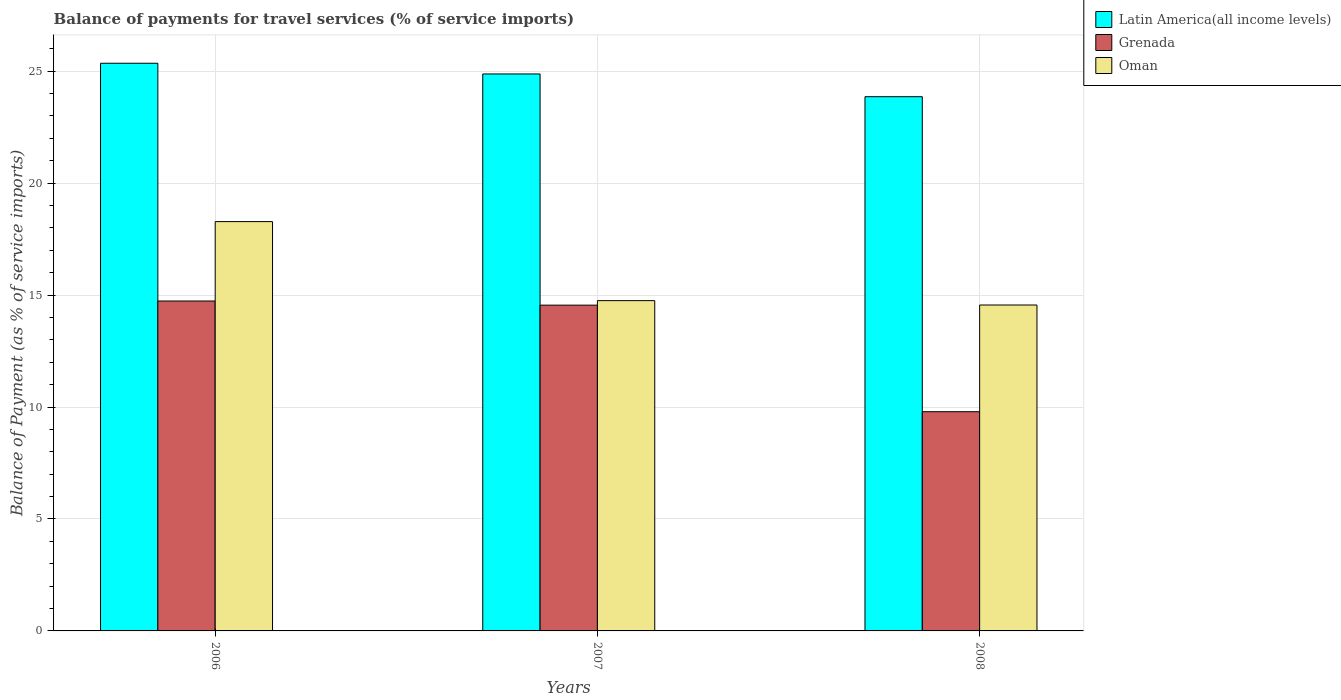How many different coloured bars are there?
Make the answer very short. 3. How many groups of bars are there?
Keep it short and to the point. 3. Are the number of bars on each tick of the X-axis equal?
Your answer should be compact. Yes. How many bars are there on the 3rd tick from the right?
Give a very brief answer. 3. What is the label of the 2nd group of bars from the left?
Provide a short and direct response. 2007. What is the balance of payments for travel services in Oman in 2007?
Provide a succinct answer. 14.75. Across all years, what is the maximum balance of payments for travel services in Oman?
Offer a very short reply. 18.28. Across all years, what is the minimum balance of payments for travel services in Latin America(all income levels)?
Offer a terse response. 23.86. In which year was the balance of payments for travel services in Latin America(all income levels) maximum?
Keep it short and to the point. 2006. In which year was the balance of payments for travel services in Latin America(all income levels) minimum?
Offer a terse response. 2008. What is the total balance of payments for travel services in Oman in the graph?
Offer a terse response. 47.59. What is the difference between the balance of payments for travel services in Latin America(all income levels) in 2006 and that in 2008?
Your answer should be compact. 1.49. What is the difference between the balance of payments for travel services in Latin America(all income levels) in 2007 and the balance of payments for travel services in Oman in 2008?
Provide a short and direct response. 10.32. What is the average balance of payments for travel services in Grenada per year?
Offer a very short reply. 13.03. In the year 2006, what is the difference between the balance of payments for travel services in Oman and balance of payments for travel services in Latin America(all income levels)?
Give a very brief answer. -7.07. In how many years, is the balance of payments for travel services in Oman greater than 2 %?
Your response must be concise. 3. What is the ratio of the balance of payments for travel services in Grenada in 2006 to that in 2007?
Provide a succinct answer. 1.01. Is the balance of payments for travel services in Grenada in 2006 less than that in 2007?
Ensure brevity in your answer.  No. What is the difference between the highest and the second highest balance of payments for travel services in Grenada?
Offer a terse response. 0.18. What is the difference between the highest and the lowest balance of payments for travel services in Latin America(all income levels)?
Offer a terse response. 1.49. Is the sum of the balance of payments for travel services in Latin America(all income levels) in 2006 and 2008 greater than the maximum balance of payments for travel services in Grenada across all years?
Keep it short and to the point. Yes. What does the 3rd bar from the left in 2007 represents?
Make the answer very short. Oman. What does the 2nd bar from the right in 2007 represents?
Your response must be concise. Grenada. Is it the case that in every year, the sum of the balance of payments for travel services in Latin America(all income levels) and balance of payments for travel services in Grenada is greater than the balance of payments for travel services in Oman?
Provide a succinct answer. Yes. How many bars are there?
Your answer should be compact. 9. Are all the bars in the graph horizontal?
Provide a short and direct response. No. Where does the legend appear in the graph?
Provide a succinct answer. Top right. How many legend labels are there?
Offer a terse response. 3. How are the legend labels stacked?
Your answer should be compact. Vertical. What is the title of the graph?
Give a very brief answer. Balance of payments for travel services (% of service imports). What is the label or title of the Y-axis?
Your answer should be very brief. Balance of Payment (as % of service imports). What is the Balance of Payment (as % of service imports) in Latin America(all income levels) in 2006?
Ensure brevity in your answer.  25.36. What is the Balance of Payment (as % of service imports) of Grenada in 2006?
Give a very brief answer. 14.74. What is the Balance of Payment (as % of service imports) in Oman in 2006?
Provide a short and direct response. 18.28. What is the Balance of Payment (as % of service imports) in Latin America(all income levels) in 2007?
Offer a very short reply. 24.88. What is the Balance of Payment (as % of service imports) in Grenada in 2007?
Offer a terse response. 14.55. What is the Balance of Payment (as % of service imports) of Oman in 2007?
Ensure brevity in your answer.  14.75. What is the Balance of Payment (as % of service imports) in Latin America(all income levels) in 2008?
Make the answer very short. 23.86. What is the Balance of Payment (as % of service imports) of Grenada in 2008?
Your answer should be very brief. 9.79. What is the Balance of Payment (as % of service imports) of Oman in 2008?
Offer a very short reply. 14.56. Across all years, what is the maximum Balance of Payment (as % of service imports) in Latin America(all income levels)?
Your response must be concise. 25.36. Across all years, what is the maximum Balance of Payment (as % of service imports) in Grenada?
Provide a succinct answer. 14.74. Across all years, what is the maximum Balance of Payment (as % of service imports) in Oman?
Provide a short and direct response. 18.28. Across all years, what is the minimum Balance of Payment (as % of service imports) of Latin America(all income levels)?
Your answer should be very brief. 23.86. Across all years, what is the minimum Balance of Payment (as % of service imports) of Grenada?
Your response must be concise. 9.79. Across all years, what is the minimum Balance of Payment (as % of service imports) of Oman?
Ensure brevity in your answer.  14.56. What is the total Balance of Payment (as % of service imports) in Latin America(all income levels) in the graph?
Ensure brevity in your answer.  74.09. What is the total Balance of Payment (as % of service imports) in Grenada in the graph?
Ensure brevity in your answer.  39.08. What is the total Balance of Payment (as % of service imports) in Oman in the graph?
Keep it short and to the point. 47.59. What is the difference between the Balance of Payment (as % of service imports) of Latin America(all income levels) in 2006 and that in 2007?
Your answer should be compact. 0.48. What is the difference between the Balance of Payment (as % of service imports) in Grenada in 2006 and that in 2007?
Your response must be concise. 0.18. What is the difference between the Balance of Payment (as % of service imports) in Oman in 2006 and that in 2007?
Make the answer very short. 3.53. What is the difference between the Balance of Payment (as % of service imports) in Latin America(all income levels) in 2006 and that in 2008?
Keep it short and to the point. 1.49. What is the difference between the Balance of Payment (as % of service imports) in Grenada in 2006 and that in 2008?
Offer a very short reply. 4.94. What is the difference between the Balance of Payment (as % of service imports) in Oman in 2006 and that in 2008?
Give a very brief answer. 3.73. What is the difference between the Balance of Payment (as % of service imports) of Latin America(all income levels) in 2007 and that in 2008?
Provide a succinct answer. 1.02. What is the difference between the Balance of Payment (as % of service imports) of Grenada in 2007 and that in 2008?
Provide a short and direct response. 4.76. What is the difference between the Balance of Payment (as % of service imports) in Oman in 2007 and that in 2008?
Provide a succinct answer. 0.19. What is the difference between the Balance of Payment (as % of service imports) of Latin America(all income levels) in 2006 and the Balance of Payment (as % of service imports) of Grenada in 2007?
Keep it short and to the point. 10.8. What is the difference between the Balance of Payment (as % of service imports) in Latin America(all income levels) in 2006 and the Balance of Payment (as % of service imports) in Oman in 2007?
Your response must be concise. 10.6. What is the difference between the Balance of Payment (as % of service imports) in Grenada in 2006 and the Balance of Payment (as % of service imports) in Oman in 2007?
Keep it short and to the point. -0.02. What is the difference between the Balance of Payment (as % of service imports) in Latin America(all income levels) in 2006 and the Balance of Payment (as % of service imports) in Grenada in 2008?
Provide a succinct answer. 15.56. What is the difference between the Balance of Payment (as % of service imports) of Latin America(all income levels) in 2006 and the Balance of Payment (as % of service imports) of Oman in 2008?
Offer a terse response. 10.8. What is the difference between the Balance of Payment (as % of service imports) of Grenada in 2006 and the Balance of Payment (as % of service imports) of Oman in 2008?
Give a very brief answer. 0.18. What is the difference between the Balance of Payment (as % of service imports) of Latin America(all income levels) in 2007 and the Balance of Payment (as % of service imports) of Grenada in 2008?
Your answer should be very brief. 15.09. What is the difference between the Balance of Payment (as % of service imports) in Latin America(all income levels) in 2007 and the Balance of Payment (as % of service imports) in Oman in 2008?
Provide a succinct answer. 10.32. What is the difference between the Balance of Payment (as % of service imports) of Grenada in 2007 and the Balance of Payment (as % of service imports) of Oman in 2008?
Keep it short and to the point. -0.01. What is the average Balance of Payment (as % of service imports) in Latin America(all income levels) per year?
Provide a short and direct response. 24.7. What is the average Balance of Payment (as % of service imports) of Grenada per year?
Keep it short and to the point. 13.03. What is the average Balance of Payment (as % of service imports) in Oman per year?
Your response must be concise. 15.86. In the year 2006, what is the difference between the Balance of Payment (as % of service imports) of Latin America(all income levels) and Balance of Payment (as % of service imports) of Grenada?
Your response must be concise. 10.62. In the year 2006, what is the difference between the Balance of Payment (as % of service imports) in Latin America(all income levels) and Balance of Payment (as % of service imports) in Oman?
Offer a terse response. 7.07. In the year 2006, what is the difference between the Balance of Payment (as % of service imports) in Grenada and Balance of Payment (as % of service imports) in Oman?
Offer a very short reply. -3.55. In the year 2007, what is the difference between the Balance of Payment (as % of service imports) in Latin America(all income levels) and Balance of Payment (as % of service imports) in Grenada?
Provide a short and direct response. 10.33. In the year 2007, what is the difference between the Balance of Payment (as % of service imports) in Latin America(all income levels) and Balance of Payment (as % of service imports) in Oman?
Your answer should be very brief. 10.12. In the year 2007, what is the difference between the Balance of Payment (as % of service imports) of Grenada and Balance of Payment (as % of service imports) of Oman?
Your answer should be compact. -0.2. In the year 2008, what is the difference between the Balance of Payment (as % of service imports) in Latin America(all income levels) and Balance of Payment (as % of service imports) in Grenada?
Give a very brief answer. 14.07. In the year 2008, what is the difference between the Balance of Payment (as % of service imports) of Latin America(all income levels) and Balance of Payment (as % of service imports) of Oman?
Keep it short and to the point. 9.3. In the year 2008, what is the difference between the Balance of Payment (as % of service imports) of Grenada and Balance of Payment (as % of service imports) of Oman?
Provide a short and direct response. -4.77. What is the ratio of the Balance of Payment (as % of service imports) of Latin America(all income levels) in 2006 to that in 2007?
Provide a succinct answer. 1.02. What is the ratio of the Balance of Payment (as % of service imports) in Grenada in 2006 to that in 2007?
Your answer should be very brief. 1.01. What is the ratio of the Balance of Payment (as % of service imports) in Oman in 2006 to that in 2007?
Make the answer very short. 1.24. What is the ratio of the Balance of Payment (as % of service imports) of Latin America(all income levels) in 2006 to that in 2008?
Give a very brief answer. 1.06. What is the ratio of the Balance of Payment (as % of service imports) of Grenada in 2006 to that in 2008?
Provide a succinct answer. 1.5. What is the ratio of the Balance of Payment (as % of service imports) in Oman in 2006 to that in 2008?
Keep it short and to the point. 1.26. What is the ratio of the Balance of Payment (as % of service imports) in Latin America(all income levels) in 2007 to that in 2008?
Offer a very short reply. 1.04. What is the ratio of the Balance of Payment (as % of service imports) in Grenada in 2007 to that in 2008?
Your response must be concise. 1.49. What is the ratio of the Balance of Payment (as % of service imports) of Oman in 2007 to that in 2008?
Keep it short and to the point. 1.01. What is the difference between the highest and the second highest Balance of Payment (as % of service imports) of Latin America(all income levels)?
Offer a very short reply. 0.48. What is the difference between the highest and the second highest Balance of Payment (as % of service imports) of Grenada?
Offer a terse response. 0.18. What is the difference between the highest and the second highest Balance of Payment (as % of service imports) in Oman?
Make the answer very short. 3.53. What is the difference between the highest and the lowest Balance of Payment (as % of service imports) in Latin America(all income levels)?
Ensure brevity in your answer.  1.49. What is the difference between the highest and the lowest Balance of Payment (as % of service imports) in Grenada?
Keep it short and to the point. 4.94. What is the difference between the highest and the lowest Balance of Payment (as % of service imports) in Oman?
Give a very brief answer. 3.73. 